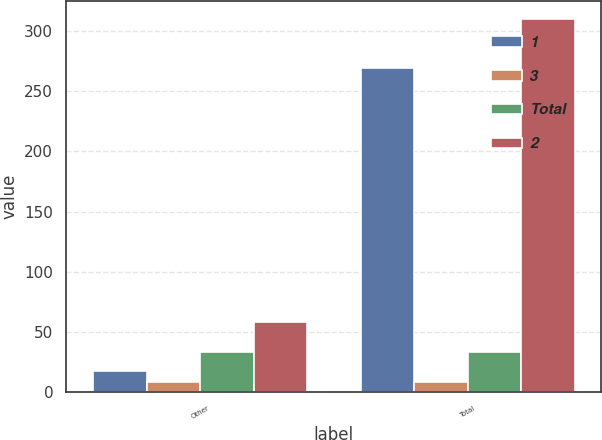Convert chart. <chart><loc_0><loc_0><loc_500><loc_500><stacked_bar_chart><ecel><fcel>Other<fcel>Total<nl><fcel>1<fcel>17<fcel>269<nl><fcel>3<fcel>8<fcel>8<nl><fcel>Total<fcel>33<fcel>33<nl><fcel>2<fcel>58<fcel>310<nl></chart> 